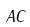<formula> <loc_0><loc_0><loc_500><loc_500>A C</formula> 